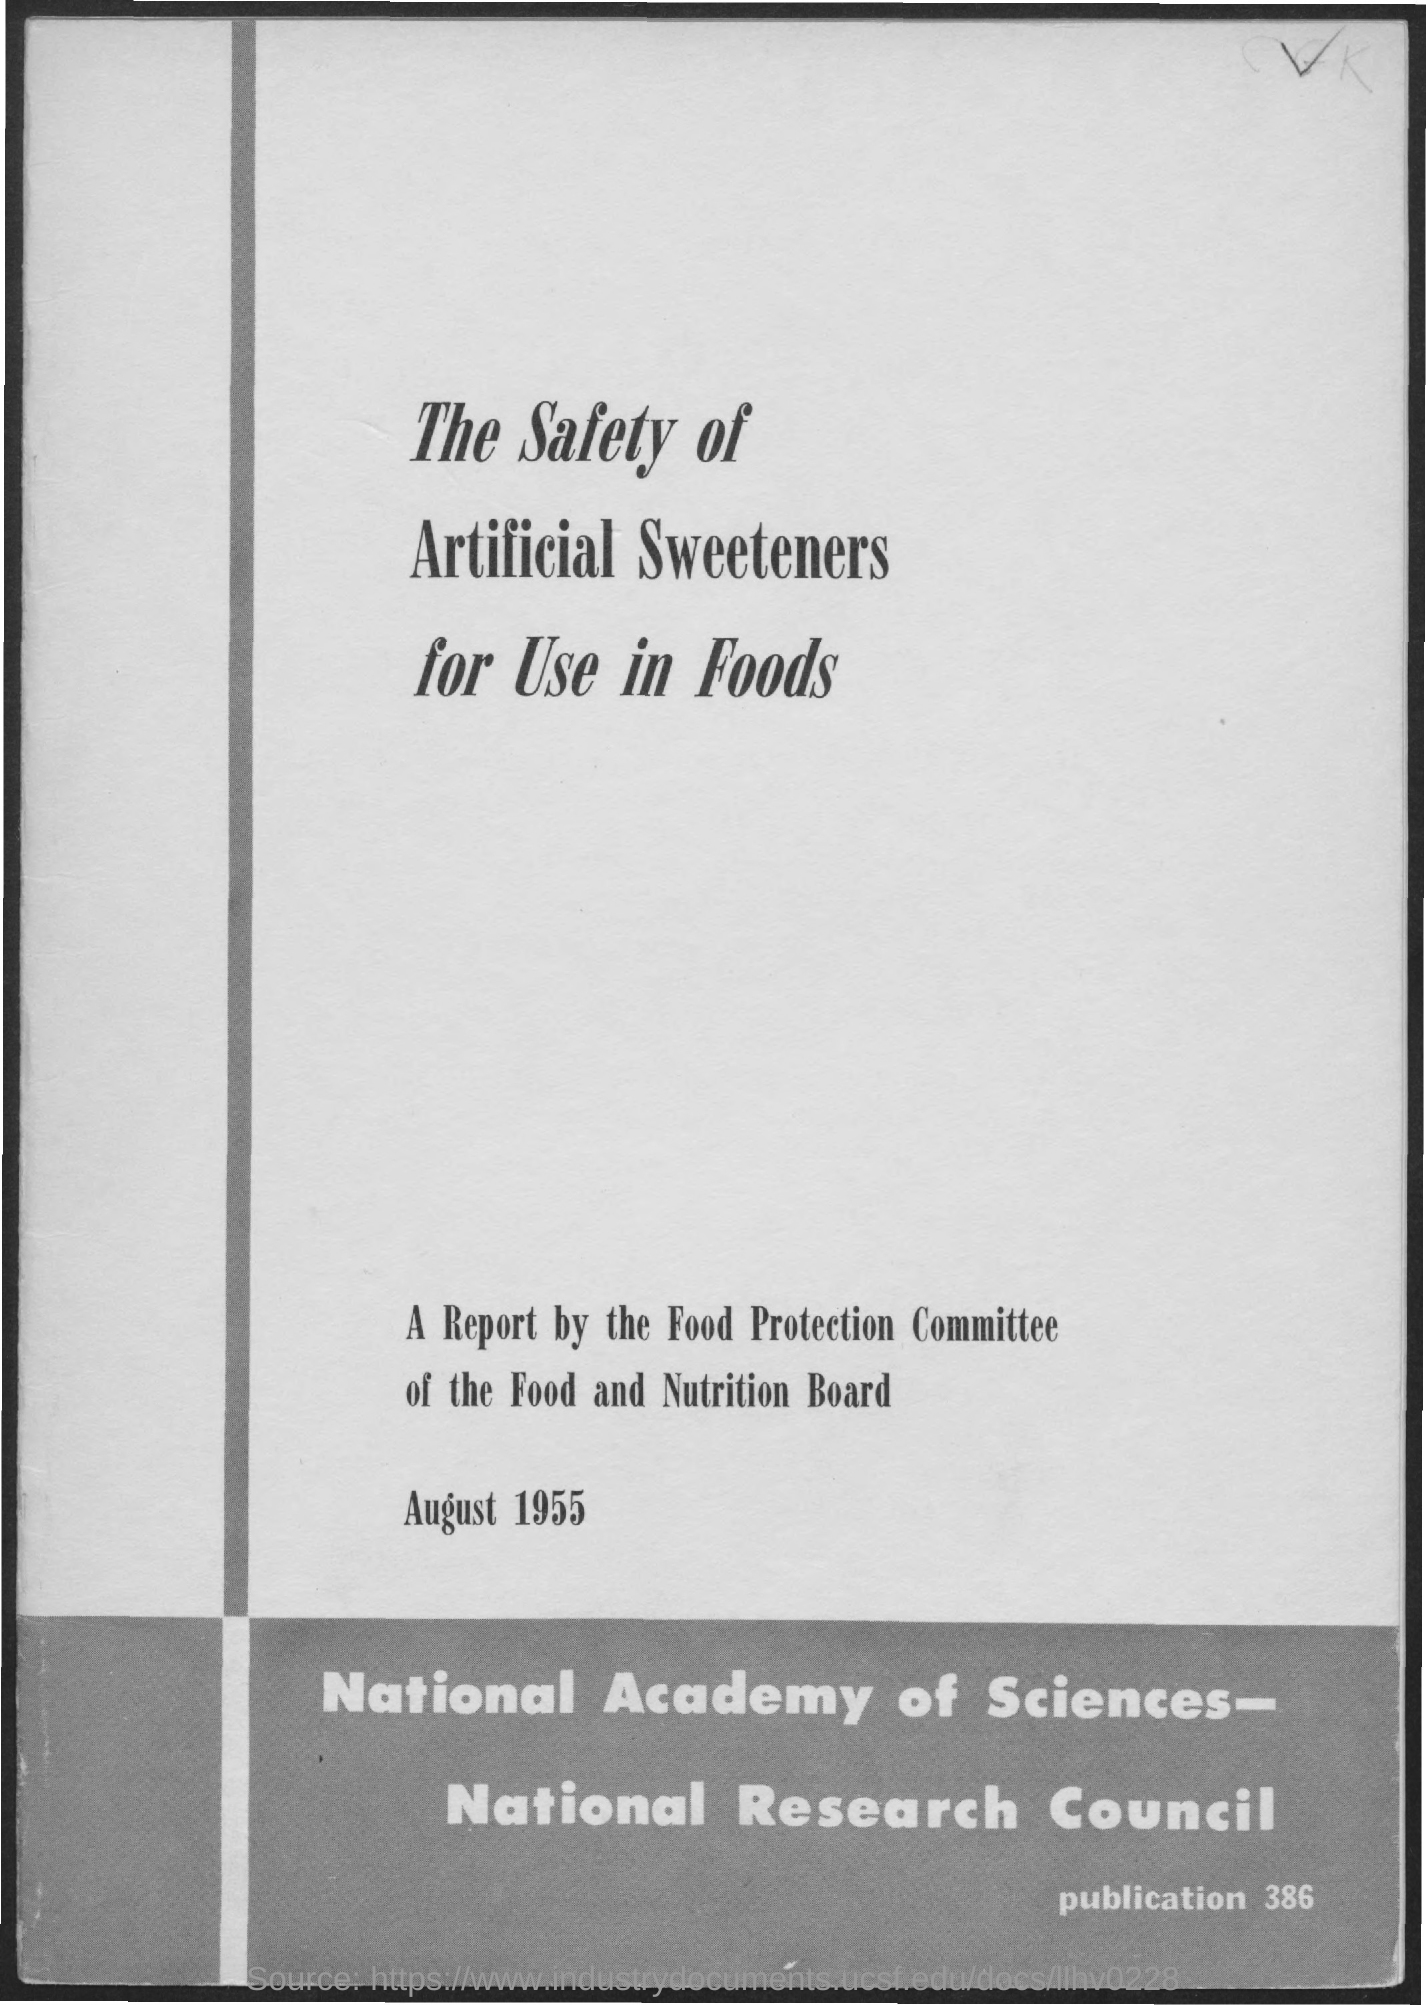Identify some key points in this picture. The Publication Number is 386. The date on the document is August 1955. 